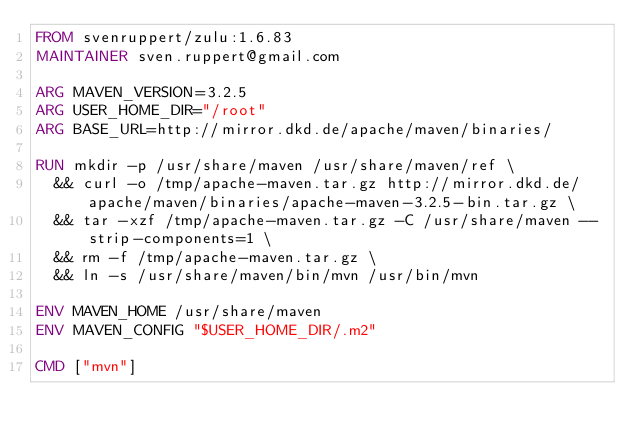Convert code to text. <code><loc_0><loc_0><loc_500><loc_500><_Dockerfile_>FROM svenruppert/zulu:1.6.83
MAINTAINER sven.ruppert@gmail.com

ARG MAVEN_VERSION=3.2.5
ARG USER_HOME_DIR="/root"
ARG BASE_URL=http://mirror.dkd.de/apache/maven/binaries/

RUN mkdir -p /usr/share/maven /usr/share/maven/ref \
  && curl -o /tmp/apache-maven.tar.gz http://mirror.dkd.de/apache/maven/binaries/apache-maven-3.2.5-bin.tar.gz \
  && tar -xzf /tmp/apache-maven.tar.gz -C /usr/share/maven --strip-components=1 \
  && rm -f /tmp/apache-maven.tar.gz \
  && ln -s /usr/share/maven/bin/mvn /usr/bin/mvn

ENV MAVEN_HOME /usr/share/maven
ENV MAVEN_CONFIG "$USER_HOME_DIR/.m2"

CMD ["mvn"]</code> 